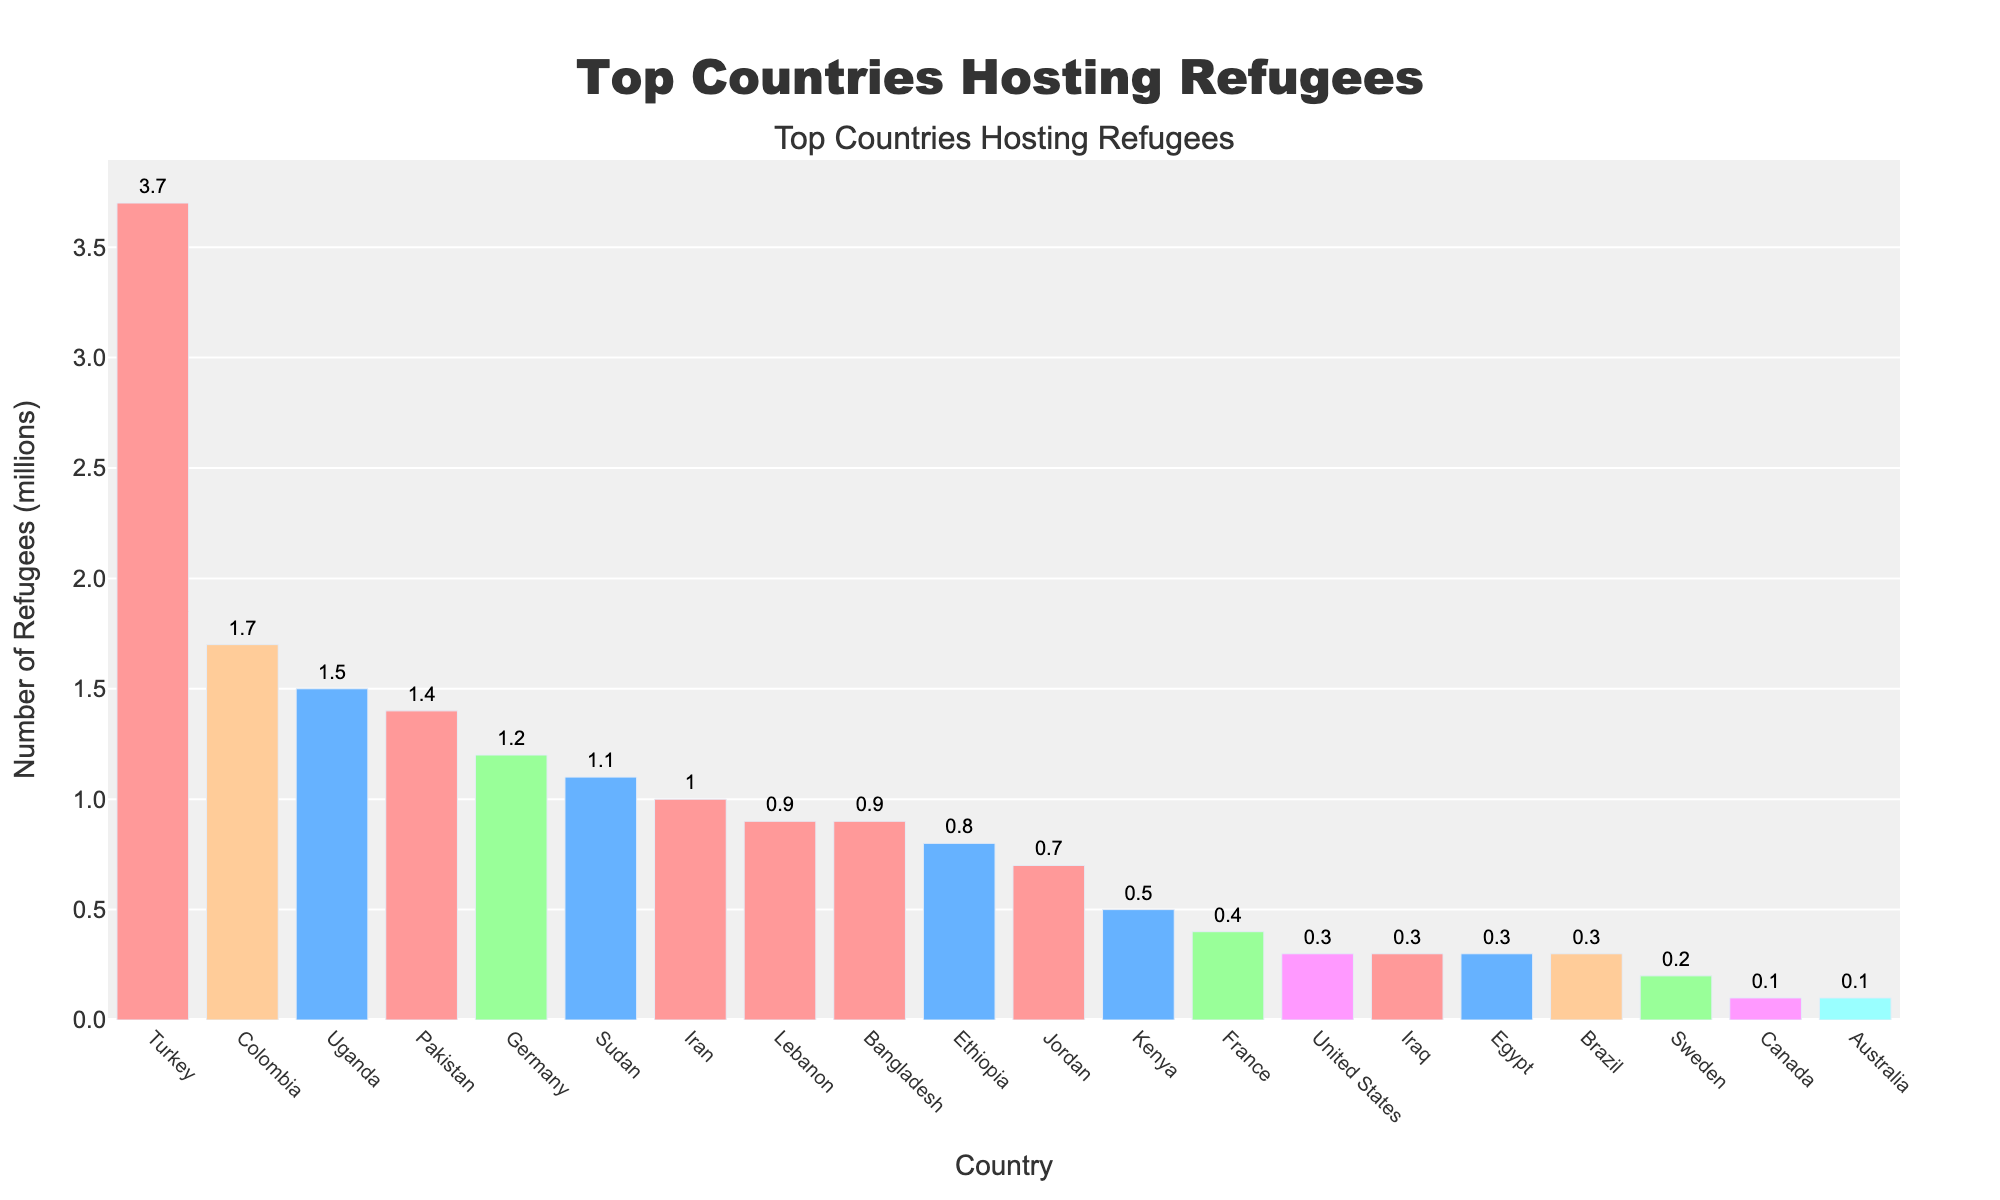Which country hosts the most refugees? By observing the figure, the bar representing Turkey is the highest among all countries, indicating it hosts the largest number of refugees.
Answer: Turkey What is the total number of refugees hosted by countries in Asia shown in the figure? Countries in Asia listed are Turkey, Pakistan, Iran, Lebanon, Bangladesh, and Jordan. Adding their numbers: 3.7 + 1.4 + 1.0 + 0.9 + 0.9 + 0.7 = 8.6 million.
Answer: 8.6 million How many more refugees does Turkey host compared to Germany? Turkey hosts 3.7 million refugees, and Germany hosts 1.2 million refugees. The difference is 3.7 - 1.2 = 2.5 million.
Answer: 2.5 million Which continent is represented the most among the top 10 refugee-hosting countries? By visual inspection, the colors representing continents show that Asia has the most countries (Turkey, Pakistan, Iran, Lebanon, Bangladesh, Jordan) in the top 10.
Answer: Asia What is the sum of refugees hosted by African countries in the top 10? The African countries listed are Uganda, Sudan, and Ethiopia. Adding their numbers: 1.5 + 1.1 + 0.8 = 3.4 million.
Answer: 3.4 million Which country hosts more refugees: Colombia or Uganda? By comparing the heights of the bars for Colombia and Uganda, Colombia's bar is higher, indicating it hosts more refugees.
Answer: Colombia Order the continents in descending order by the total number of refugees they host based on the top 10 countries. Summing the refugees for each continent: Asia (3.7 + 1.4 + 1.0 + 0.9 + 0.9 + 0.7 = 8.6), Africa (1.5 + 1.1 + 0.8 = 3.4), Europe (1.2), South America (1.7), North America (0.3), Oceania (0). Order: Asia > Africa > Europe > South America > North America > Oceania.
Answer: Asia, Africa, Europe, South America, North America, Oceania Which country in Europe hosts the most refugees, and how many? Among the European countries, Germany, France, and Sweden are listed. Germany has the highest bar, hosting 1.2 million refugees.
Answer: Germany, 1.2 million What is the difference in the number of refugees hosted by Uganda and Ethiopia? Uganda hosts 1.5 million refugees, and Ethiopia hosts 0.8 million. The difference is 1.5 - 0.8 = 0.7 million.
Answer: 0.7 million 